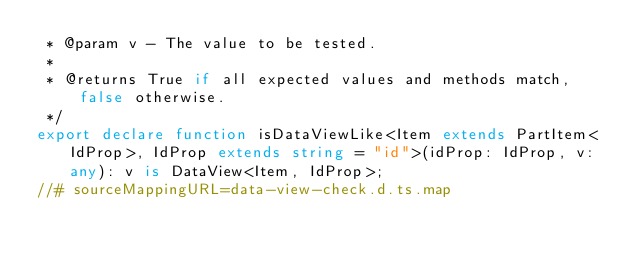Convert code to text. <code><loc_0><loc_0><loc_500><loc_500><_TypeScript_> * @param v - The value to be tested.
 *
 * @returns True if all expected values and methods match, false otherwise.
 */
export declare function isDataViewLike<Item extends PartItem<IdProp>, IdProp extends string = "id">(idProp: IdProp, v: any): v is DataView<Item, IdProp>;
//# sourceMappingURL=data-view-check.d.ts.map</code> 